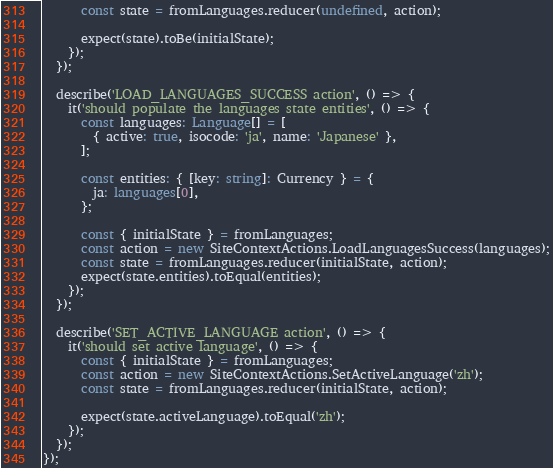Convert code to text. <code><loc_0><loc_0><loc_500><loc_500><_TypeScript_>      const state = fromLanguages.reducer(undefined, action);

      expect(state).toBe(initialState);
    });
  });

  describe('LOAD_LANGUAGES_SUCCESS action', () => {
    it('should populate the languages state entities', () => {
      const languages: Language[] = [
        { active: true, isocode: 'ja', name: 'Japanese' },
      ];

      const entities: { [key: string]: Currency } = {
        ja: languages[0],
      };

      const { initialState } = fromLanguages;
      const action = new SiteContextActions.LoadLanguagesSuccess(languages);
      const state = fromLanguages.reducer(initialState, action);
      expect(state.entities).toEqual(entities);
    });
  });

  describe('SET_ACTIVE_LANGUAGE action', () => {
    it('should set active language', () => {
      const { initialState } = fromLanguages;
      const action = new SiteContextActions.SetActiveLanguage('zh');
      const state = fromLanguages.reducer(initialState, action);

      expect(state.activeLanguage).toEqual('zh');
    });
  });
});
</code> 